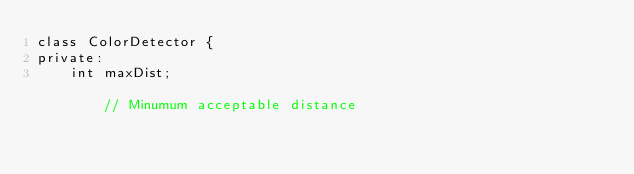Convert code to text. <code><loc_0><loc_0><loc_500><loc_500><_C++_>class ColorDetector {
private:
    int maxDist;                                                                // Minumum acceptable distance</code> 